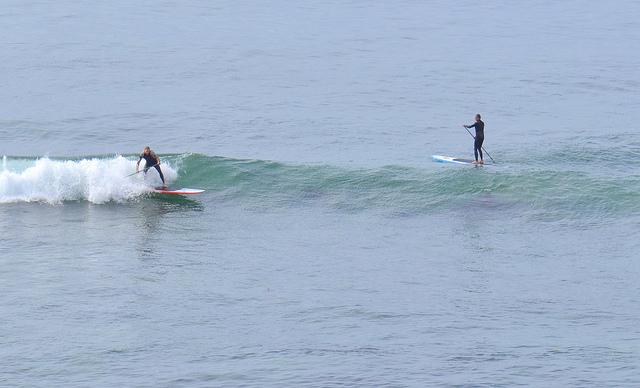Is the water cold?
Give a very brief answer. No. Is the water placid?
Keep it brief. No. Can these people drain?
Write a very short answer. No. How deep is the water?
Concise answer only. Deep. 